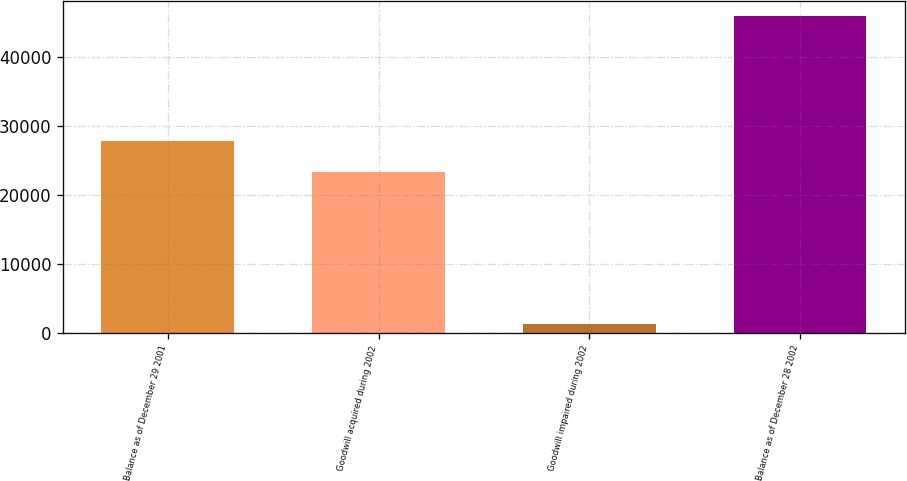Convert chart to OTSL. <chart><loc_0><loc_0><loc_500><loc_500><bar_chart><fcel>Balance as of December 29 2001<fcel>Goodwill acquired during 2002<fcel>Goodwill impaired during 2002<fcel>Balance as of December 28 2002<nl><fcel>27797.6<fcel>23331<fcel>1272<fcel>45938<nl></chart> 